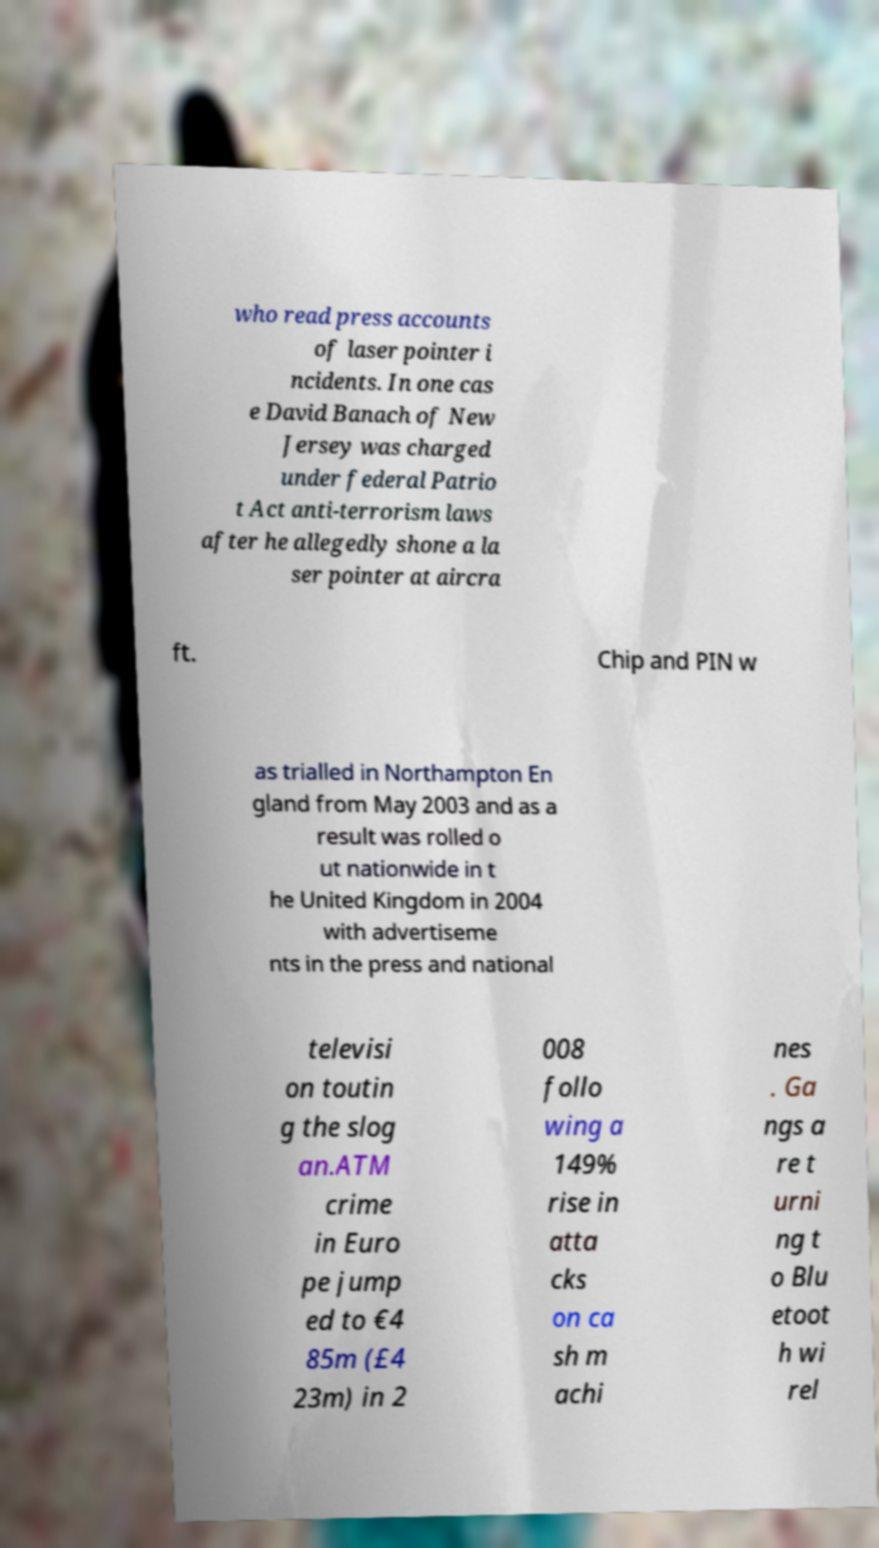Please read and relay the text visible in this image. What does it say? who read press accounts of laser pointer i ncidents. In one cas e David Banach of New Jersey was charged under federal Patrio t Act anti-terrorism laws after he allegedly shone a la ser pointer at aircra ft. Chip and PIN w as trialled in Northampton En gland from May 2003 and as a result was rolled o ut nationwide in t he United Kingdom in 2004 with advertiseme nts in the press and national televisi on toutin g the slog an.ATM crime in Euro pe jump ed to €4 85m (£4 23m) in 2 008 follo wing a 149% rise in atta cks on ca sh m achi nes . Ga ngs a re t urni ng t o Blu etoot h wi rel 